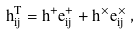Convert formula to latex. <formula><loc_0><loc_0><loc_500><loc_500>h ^ { T } _ { i j } = h ^ { + } e ^ { + } _ { i j } + h ^ { \times } e ^ { \times } _ { i j } \, ,</formula> 